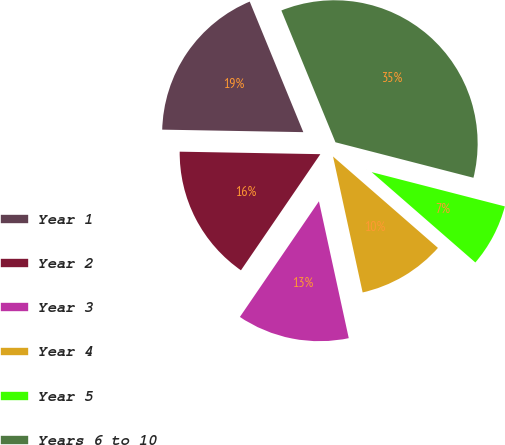Convert chart to OTSL. <chart><loc_0><loc_0><loc_500><loc_500><pie_chart><fcel>Year 1<fcel>Year 2<fcel>Year 3<fcel>Year 4<fcel>Year 5<fcel>Years 6 to 10<nl><fcel>18.52%<fcel>15.74%<fcel>12.96%<fcel>10.18%<fcel>7.4%<fcel>35.21%<nl></chart> 